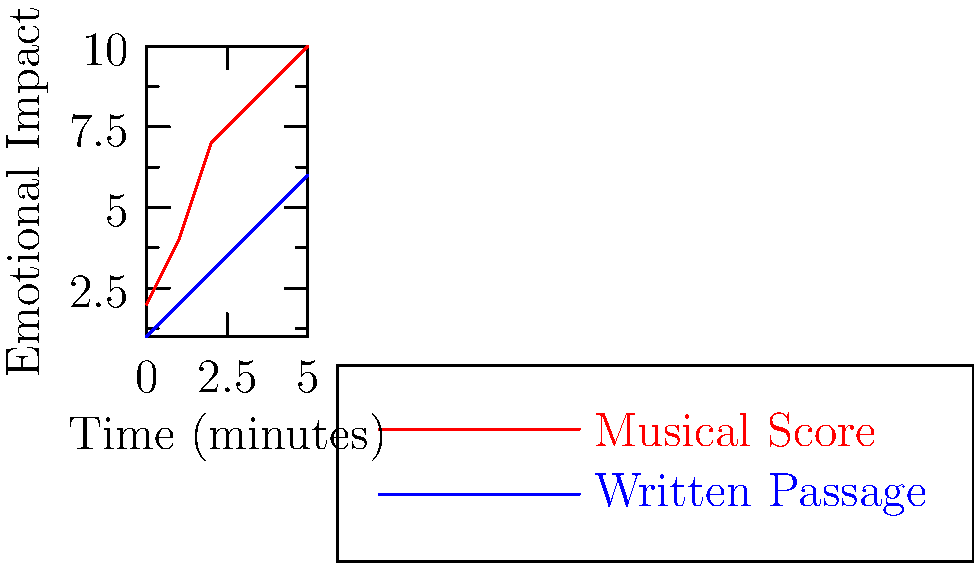The graph shows the emotional impact of a musical score and a written passage over time. At what point in time does the difference in emotional impact between the musical score and the written passage become the greatest? To find the point where the difference in emotional impact is greatest, we need to:

1. Calculate the difference between the musical score and written passage at each time point.
2. Identify the largest difference.

Differences at each time point:
t=0: 2-1 = 1
t=1: 4-2 = 2
t=2: 7-3 = 4
t=3: 8-4 = 4
t=4: 9-5 = 4
t=5: 10-6 = 4

The largest difference is 4, which first occurs at t=2 and remains constant until t=5.

Since we're asked for the point where the difference becomes the greatest, we choose the earliest time this occurs, which is at t=2.
Answer: 2 minutes 